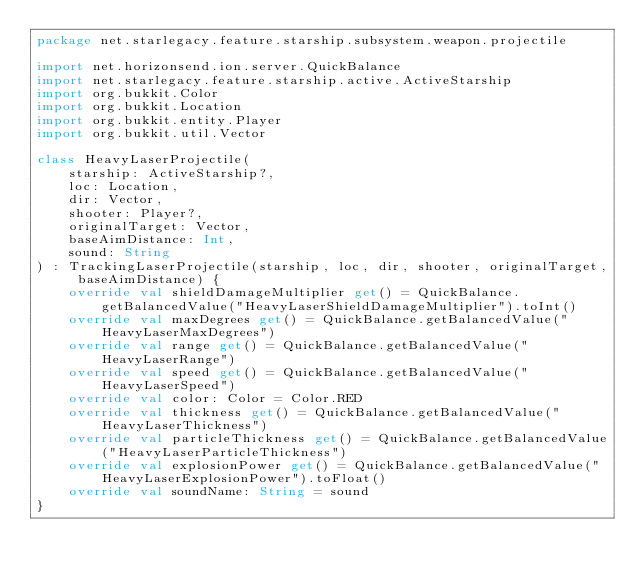<code> <loc_0><loc_0><loc_500><loc_500><_Kotlin_>package net.starlegacy.feature.starship.subsystem.weapon.projectile

import net.horizonsend.ion.server.QuickBalance
import net.starlegacy.feature.starship.active.ActiveStarship
import org.bukkit.Color
import org.bukkit.Location
import org.bukkit.entity.Player
import org.bukkit.util.Vector

class HeavyLaserProjectile(
	starship: ActiveStarship?,
	loc: Location,
	dir: Vector,
	shooter: Player?,
	originalTarget: Vector,
	baseAimDistance: Int,
	sound: String
) : TrackingLaserProjectile(starship, loc, dir, shooter, originalTarget, baseAimDistance) {
	override val shieldDamageMultiplier get() = QuickBalance.getBalancedValue("HeavyLaserShieldDamageMultiplier").toInt()
	override val maxDegrees get() = QuickBalance.getBalancedValue("HeavyLaserMaxDegrees")
	override val range get() = QuickBalance.getBalancedValue("HeavyLaserRange")
	override val speed get() = QuickBalance.getBalancedValue("HeavyLaserSpeed")
	override val color: Color = Color.RED
	override val thickness get() = QuickBalance.getBalancedValue("HeavyLaserThickness")
	override val particleThickness get() = QuickBalance.getBalancedValue("HeavyLaserParticleThickness")
	override val explosionPower get() = QuickBalance.getBalancedValue("HeavyLaserExplosionPower").toFloat()
	override val soundName: String = sound
}
</code> 